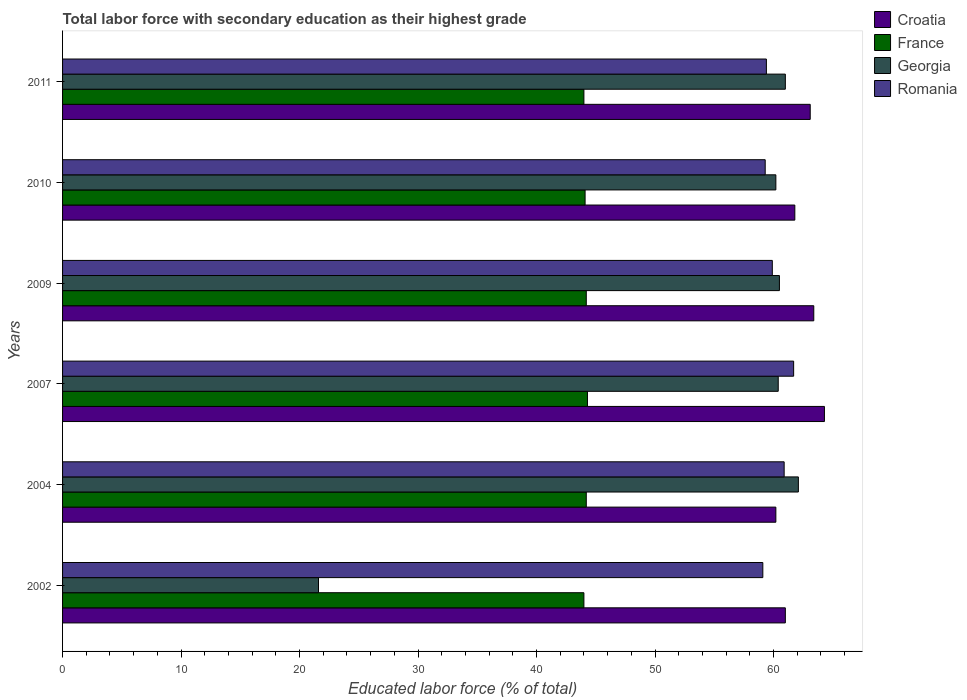How many different coloured bars are there?
Keep it short and to the point. 4. Are the number of bars per tick equal to the number of legend labels?
Offer a very short reply. Yes. Are the number of bars on each tick of the Y-axis equal?
Provide a succinct answer. Yes. How many bars are there on the 5th tick from the top?
Offer a terse response. 4. How many bars are there on the 4th tick from the bottom?
Your response must be concise. 4. In how many cases, is the number of bars for a given year not equal to the number of legend labels?
Keep it short and to the point. 0. What is the percentage of total labor force with primary education in Croatia in 2004?
Offer a terse response. 60.2. Across all years, what is the maximum percentage of total labor force with primary education in Georgia?
Provide a short and direct response. 62.1. Across all years, what is the minimum percentage of total labor force with primary education in France?
Provide a succinct answer. 44. What is the total percentage of total labor force with primary education in Croatia in the graph?
Your answer should be compact. 373.8. What is the difference between the percentage of total labor force with primary education in Romania in 2004 and that in 2010?
Provide a short and direct response. 1.6. What is the difference between the percentage of total labor force with primary education in Romania in 2009 and the percentage of total labor force with primary education in Georgia in 2011?
Offer a terse response. -1.1. What is the average percentage of total labor force with primary education in Georgia per year?
Offer a terse response. 54.3. In the year 2002, what is the difference between the percentage of total labor force with primary education in France and percentage of total labor force with primary education in Georgia?
Provide a succinct answer. 22.4. In how many years, is the percentage of total labor force with primary education in Georgia greater than 60 %?
Offer a very short reply. 5. What is the ratio of the percentage of total labor force with primary education in Croatia in 2009 to that in 2011?
Provide a short and direct response. 1. Is the difference between the percentage of total labor force with primary education in France in 2004 and 2007 greater than the difference between the percentage of total labor force with primary education in Georgia in 2004 and 2007?
Offer a very short reply. No. What is the difference between the highest and the second highest percentage of total labor force with primary education in Georgia?
Your response must be concise. 1.1. What is the difference between the highest and the lowest percentage of total labor force with primary education in Croatia?
Provide a succinct answer. 4.1. Is the sum of the percentage of total labor force with primary education in Croatia in 2007 and 2010 greater than the maximum percentage of total labor force with primary education in France across all years?
Make the answer very short. Yes. Is it the case that in every year, the sum of the percentage of total labor force with primary education in Romania and percentage of total labor force with primary education in Croatia is greater than the sum of percentage of total labor force with primary education in Georgia and percentage of total labor force with primary education in France?
Provide a short and direct response. No. What does the 2nd bar from the top in 2007 represents?
Provide a short and direct response. Georgia. What does the 4th bar from the bottom in 2010 represents?
Ensure brevity in your answer.  Romania. How many bars are there?
Provide a short and direct response. 24. Are all the bars in the graph horizontal?
Keep it short and to the point. Yes. What is the difference between two consecutive major ticks on the X-axis?
Offer a very short reply. 10. Does the graph contain any zero values?
Provide a succinct answer. No. Does the graph contain grids?
Your answer should be very brief. No. What is the title of the graph?
Keep it short and to the point. Total labor force with secondary education as their highest grade. What is the label or title of the X-axis?
Make the answer very short. Educated labor force (% of total). What is the Educated labor force (% of total) of Croatia in 2002?
Offer a very short reply. 61. What is the Educated labor force (% of total) of Georgia in 2002?
Offer a very short reply. 21.6. What is the Educated labor force (% of total) in Romania in 2002?
Offer a very short reply. 59.1. What is the Educated labor force (% of total) in Croatia in 2004?
Provide a short and direct response. 60.2. What is the Educated labor force (% of total) in France in 2004?
Make the answer very short. 44.2. What is the Educated labor force (% of total) in Georgia in 2004?
Your response must be concise. 62.1. What is the Educated labor force (% of total) of Romania in 2004?
Give a very brief answer. 60.9. What is the Educated labor force (% of total) of Croatia in 2007?
Provide a succinct answer. 64.3. What is the Educated labor force (% of total) of France in 2007?
Keep it short and to the point. 44.3. What is the Educated labor force (% of total) in Georgia in 2007?
Your response must be concise. 60.4. What is the Educated labor force (% of total) in Romania in 2007?
Offer a very short reply. 61.7. What is the Educated labor force (% of total) of Croatia in 2009?
Your answer should be compact. 63.4. What is the Educated labor force (% of total) of France in 2009?
Provide a short and direct response. 44.2. What is the Educated labor force (% of total) in Georgia in 2009?
Keep it short and to the point. 60.5. What is the Educated labor force (% of total) in Romania in 2009?
Your answer should be very brief. 59.9. What is the Educated labor force (% of total) in Croatia in 2010?
Make the answer very short. 61.8. What is the Educated labor force (% of total) of France in 2010?
Provide a succinct answer. 44.1. What is the Educated labor force (% of total) of Georgia in 2010?
Offer a terse response. 60.2. What is the Educated labor force (% of total) in Romania in 2010?
Provide a short and direct response. 59.3. What is the Educated labor force (% of total) in Croatia in 2011?
Offer a terse response. 63.1. What is the Educated labor force (% of total) of France in 2011?
Provide a short and direct response. 44. What is the Educated labor force (% of total) of Romania in 2011?
Keep it short and to the point. 59.4. Across all years, what is the maximum Educated labor force (% of total) in Croatia?
Provide a succinct answer. 64.3. Across all years, what is the maximum Educated labor force (% of total) of France?
Your response must be concise. 44.3. Across all years, what is the maximum Educated labor force (% of total) in Georgia?
Make the answer very short. 62.1. Across all years, what is the maximum Educated labor force (% of total) of Romania?
Offer a terse response. 61.7. Across all years, what is the minimum Educated labor force (% of total) of Croatia?
Your answer should be compact. 60.2. Across all years, what is the minimum Educated labor force (% of total) of France?
Offer a very short reply. 44. Across all years, what is the minimum Educated labor force (% of total) in Georgia?
Your answer should be very brief. 21.6. Across all years, what is the minimum Educated labor force (% of total) of Romania?
Your answer should be compact. 59.1. What is the total Educated labor force (% of total) in Croatia in the graph?
Offer a very short reply. 373.8. What is the total Educated labor force (% of total) of France in the graph?
Offer a terse response. 264.8. What is the total Educated labor force (% of total) in Georgia in the graph?
Your answer should be compact. 325.8. What is the total Educated labor force (% of total) in Romania in the graph?
Offer a very short reply. 360.3. What is the difference between the Educated labor force (% of total) in Croatia in 2002 and that in 2004?
Your response must be concise. 0.8. What is the difference between the Educated labor force (% of total) of Georgia in 2002 and that in 2004?
Offer a very short reply. -40.5. What is the difference between the Educated labor force (% of total) of Romania in 2002 and that in 2004?
Provide a short and direct response. -1.8. What is the difference between the Educated labor force (% of total) in Croatia in 2002 and that in 2007?
Your answer should be very brief. -3.3. What is the difference between the Educated labor force (% of total) in Georgia in 2002 and that in 2007?
Your answer should be compact. -38.8. What is the difference between the Educated labor force (% of total) in Georgia in 2002 and that in 2009?
Provide a succinct answer. -38.9. What is the difference between the Educated labor force (% of total) in Croatia in 2002 and that in 2010?
Provide a succinct answer. -0.8. What is the difference between the Educated labor force (% of total) of Georgia in 2002 and that in 2010?
Offer a terse response. -38.6. What is the difference between the Educated labor force (% of total) of France in 2002 and that in 2011?
Your answer should be very brief. 0. What is the difference between the Educated labor force (% of total) in Georgia in 2002 and that in 2011?
Make the answer very short. -39.4. What is the difference between the Educated labor force (% of total) in Croatia in 2004 and that in 2007?
Ensure brevity in your answer.  -4.1. What is the difference between the Educated labor force (% of total) of France in 2004 and that in 2009?
Provide a short and direct response. 0. What is the difference between the Educated labor force (% of total) of Croatia in 2004 and that in 2010?
Your response must be concise. -1.6. What is the difference between the Educated labor force (% of total) in France in 2004 and that in 2010?
Your answer should be very brief. 0.1. What is the difference between the Educated labor force (% of total) in Croatia in 2007 and that in 2009?
Provide a short and direct response. 0.9. What is the difference between the Educated labor force (% of total) in France in 2007 and that in 2009?
Your answer should be compact. 0.1. What is the difference between the Educated labor force (% of total) of Georgia in 2007 and that in 2010?
Provide a short and direct response. 0.2. What is the difference between the Educated labor force (% of total) of Georgia in 2007 and that in 2011?
Provide a succinct answer. -0.6. What is the difference between the Educated labor force (% of total) in Croatia in 2009 and that in 2011?
Give a very brief answer. 0.3. What is the difference between the Educated labor force (% of total) of Romania in 2009 and that in 2011?
Provide a short and direct response. 0.5. What is the difference between the Educated labor force (% of total) of France in 2010 and that in 2011?
Ensure brevity in your answer.  0.1. What is the difference between the Educated labor force (% of total) of Croatia in 2002 and the Educated labor force (% of total) of France in 2004?
Your response must be concise. 16.8. What is the difference between the Educated labor force (% of total) of Croatia in 2002 and the Educated labor force (% of total) of Georgia in 2004?
Keep it short and to the point. -1.1. What is the difference between the Educated labor force (% of total) of France in 2002 and the Educated labor force (% of total) of Georgia in 2004?
Provide a short and direct response. -18.1. What is the difference between the Educated labor force (% of total) in France in 2002 and the Educated labor force (% of total) in Romania in 2004?
Ensure brevity in your answer.  -16.9. What is the difference between the Educated labor force (% of total) in Georgia in 2002 and the Educated labor force (% of total) in Romania in 2004?
Provide a short and direct response. -39.3. What is the difference between the Educated labor force (% of total) in Croatia in 2002 and the Educated labor force (% of total) in Georgia in 2007?
Give a very brief answer. 0.6. What is the difference between the Educated labor force (% of total) of France in 2002 and the Educated labor force (% of total) of Georgia in 2007?
Provide a succinct answer. -16.4. What is the difference between the Educated labor force (% of total) of France in 2002 and the Educated labor force (% of total) of Romania in 2007?
Your answer should be very brief. -17.7. What is the difference between the Educated labor force (% of total) of Georgia in 2002 and the Educated labor force (% of total) of Romania in 2007?
Offer a very short reply. -40.1. What is the difference between the Educated labor force (% of total) in Croatia in 2002 and the Educated labor force (% of total) in Georgia in 2009?
Provide a short and direct response. 0.5. What is the difference between the Educated labor force (% of total) of France in 2002 and the Educated labor force (% of total) of Georgia in 2009?
Give a very brief answer. -16.5. What is the difference between the Educated labor force (% of total) of France in 2002 and the Educated labor force (% of total) of Romania in 2009?
Keep it short and to the point. -15.9. What is the difference between the Educated labor force (% of total) in Georgia in 2002 and the Educated labor force (% of total) in Romania in 2009?
Your answer should be compact. -38.3. What is the difference between the Educated labor force (% of total) of Croatia in 2002 and the Educated labor force (% of total) of Romania in 2010?
Offer a very short reply. 1.7. What is the difference between the Educated labor force (% of total) of France in 2002 and the Educated labor force (% of total) of Georgia in 2010?
Offer a terse response. -16.2. What is the difference between the Educated labor force (% of total) of France in 2002 and the Educated labor force (% of total) of Romania in 2010?
Offer a very short reply. -15.3. What is the difference between the Educated labor force (% of total) of Georgia in 2002 and the Educated labor force (% of total) of Romania in 2010?
Make the answer very short. -37.7. What is the difference between the Educated labor force (% of total) in France in 2002 and the Educated labor force (% of total) in Romania in 2011?
Offer a very short reply. -15.4. What is the difference between the Educated labor force (% of total) of Georgia in 2002 and the Educated labor force (% of total) of Romania in 2011?
Provide a short and direct response. -37.8. What is the difference between the Educated labor force (% of total) in Croatia in 2004 and the Educated labor force (% of total) in Georgia in 2007?
Give a very brief answer. -0.2. What is the difference between the Educated labor force (% of total) of Croatia in 2004 and the Educated labor force (% of total) of Romania in 2007?
Offer a terse response. -1.5. What is the difference between the Educated labor force (% of total) in France in 2004 and the Educated labor force (% of total) in Georgia in 2007?
Your answer should be compact. -16.2. What is the difference between the Educated labor force (% of total) in France in 2004 and the Educated labor force (% of total) in Romania in 2007?
Offer a terse response. -17.5. What is the difference between the Educated labor force (% of total) of Georgia in 2004 and the Educated labor force (% of total) of Romania in 2007?
Your answer should be compact. 0.4. What is the difference between the Educated labor force (% of total) of Croatia in 2004 and the Educated labor force (% of total) of Romania in 2009?
Offer a terse response. 0.3. What is the difference between the Educated labor force (% of total) in France in 2004 and the Educated labor force (% of total) in Georgia in 2009?
Provide a short and direct response. -16.3. What is the difference between the Educated labor force (% of total) of France in 2004 and the Educated labor force (% of total) of Romania in 2009?
Provide a short and direct response. -15.7. What is the difference between the Educated labor force (% of total) in Croatia in 2004 and the Educated labor force (% of total) in France in 2010?
Provide a succinct answer. 16.1. What is the difference between the Educated labor force (% of total) of Croatia in 2004 and the Educated labor force (% of total) of Georgia in 2010?
Your response must be concise. 0. What is the difference between the Educated labor force (% of total) in Croatia in 2004 and the Educated labor force (% of total) in Romania in 2010?
Your response must be concise. 0.9. What is the difference between the Educated labor force (% of total) in France in 2004 and the Educated labor force (% of total) in Georgia in 2010?
Make the answer very short. -16. What is the difference between the Educated labor force (% of total) of France in 2004 and the Educated labor force (% of total) of Romania in 2010?
Provide a succinct answer. -15.1. What is the difference between the Educated labor force (% of total) of Croatia in 2004 and the Educated labor force (% of total) of France in 2011?
Give a very brief answer. 16.2. What is the difference between the Educated labor force (% of total) in Croatia in 2004 and the Educated labor force (% of total) in Romania in 2011?
Offer a terse response. 0.8. What is the difference between the Educated labor force (% of total) in France in 2004 and the Educated labor force (% of total) in Georgia in 2011?
Your answer should be very brief. -16.8. What is the difference between the Educated labor force (% of total) of France in 2004 and the Educated labor force (% of total) of Romania in 2011?
Keep it short and to the point. -15.2. What is the difference between the Educated labor force (% of total) in Georgia in 2004 and the Educated labor force (% of total) in Romania in 2011?
Your answer should be very brief. 2.7. What is the difference between the Educated labor force (% of total) of Croatia in 2007 and the Educated labor force (% of total) of France in 2009?
Your answer should be compact. 20.1. What is the difference between the Educated labor force (% of total) in Croatia in 2007 and the Educated labor force (% of total) in Romania in 2009?
Provide a succinct answer. 4.4. What is the difference between the Educated labor force (% of total) of France in 2007 and the Educated labor force (% of total) of Georgia in 2009?
Offer a terse response. -16.2. What is the difference between the Educated labor force (% of total) of France in 2007 and the Educated labor force (% of total) of Romania in 2009?
Offer a terse response. -15.6. What is the difference between the Educated labor force (% of total) of Georgia in 2007 and the Educated labor force (% of total) of Romania in 2009?
Offer a very short reply. 0.5. What is the difference between the Educated labor force (% of total) of Croatia in 2007 and the Educated labor force (% of total) of France in 2010?
Offer a terse response. 20.2. What is the difference between the Educated labor force (% of total) in Croatia in 2007 and the Educated labor force (% of total) in Georgia in 2010?
Offer a terse response. 4.1. What is the difference between the Educated labor force (% of total) in France in 2007 and the Educated labor force (% of total) in Georgia in 2010?
Ensure brevity in your answer.  -15.9. What is the difference between the Educated labor force (% of total) of France in 2007 and the Educated labor force (% of total) of Romania in 2010?
Offer a terse response. -15. What is the difference between the Educated labor force (% of total) of Croatia in 2007 and the Educated labor force (% of total) of France in 2011?
Your response must be concise. 20.3. What is the difference between the Educated labor force (% of total) in Croatia in 2007 and the Educated labor force (% of total) in Romania in 2011?
Offer a very short reply. 4.9. What is the difference between the Educated labor force (% of total) of France in 2007 and the Educated labor force (% of total) of Georgia in 2011?
Offer a very short reply. -16.7. What is the difference between the Educated labor force (% of total) of France in 2007 and the Educated labor force (% of total) of Romania in 2011?
Provide a short and direct response. -15.1. What is the difference between the Educated labor force (% of total) of Georgia in 2007 and the Educated labor force (% of total) of Romania in 2011?
Your answer should be very brief. 1. What is the difference between the Educated labor force (% of total) in Croatia in 2009 and the Educated labor force (% of total) in France in 2010?
Make the answer very short. 19.3. What is the difference between the Educated labor force (% of total) of Croatia in 2009 and the Educated labor force (% of total) of Georgia in 2010?
Ensure brevity in your answer.  3.2. What is the difference between the Educated labor force (% of total) in Croatia in 2009 and the Educated labor force (% of total) in Romania in 2010?
Give a very brief answer. 4.1. What is the difference between the Educated labor force (% of total) of France in 2009 and the Educated labor force (% of total) of Romania in 2010?
Ensure brevity in your answer.  -15.1. What is the difference between the Educated labor force (% of total) in Georgia in 2009 and the Educated labor force (% of total) in Romania in 2010?
Your response must be concise. 1.2. What is the difference between the Educated labor force (% of total) of France in 2009 and the Educated labor force (% of total) of Georgia in 2011?
Offer a very short reply. -16.8. What is the difference between the Educated labor force (% of total) of France in 2009 and the Educated labor force (% of total) of Romania in 2011?
Make the answer very short. -15.2. What is the difference between the Educated labor force (% of total) in Georgia in 2009 and the Educated labor force (% of total) in Romania in 2011?
Offer a very short reply. 1.1. What is the difference between the Educated labor force (% of total) of Croatia in 2010 and the Educated labor force (% of total) of France in 2011?
Offer a very short reply. 17.8. What is the difference between the Educated labor force (% of total) of Croatia in 2010 and the Educated labor force (% of total) of Georgia in 2011?
Ensure brevity in your answer.  0.8. What is the difference between the Educated labor force (% of total) in France in 2010 and the Educated labor force (% of total) in Georgia in 2011?
Your response must be concise. -16.9. What is the difference between the Educated labor force (% of total) in France in 2010 and the Educated labor force (% of total) in Romania in 2011?
Your answer should be compact. -15.3. What is the average Educated labor force (% of total) in Croatia per year?
Provide a succinct answer. 62.3. What is the average Educated labor force (% of total) of France per year?
Keep it short and to the point. 44.13. What is the average Educated labor force (% of total) in Georgia per year?
Offer a very short reply. 54.3. What is the average Educated labor force (% of total) of Romania per year?
Ensure brevity in your answer.  60.05. In the year 2002, what is the difference between the Educated labor force (% of total) of Croatia and Educated labor force (% of total) of France?
Give a very brief answer. 17. In the year 2002, what is the difference between the Educated labor force (% of total) of Croatia and Educated labor force (% of total) of Georgia?
Provide a short and direct response. 39.4. In the year 2002, what is the difference between the Educated labor force (% of total) in Croatia and Educated labor force (% of total) in Romania?
Offer a terse response. 1.9. In the year 2002, what is the difference between the Educated labor force (% of total) of France and Educated labor force (% of total) of Georgia?
Offer a terse response. 22.4. In the year 2002, what is the difference between the Educated labor force (% of total) of France and Educated labor force (% of total) of Romania?
Keep it short and to the point. -15.1. In the year 2002, what is the difference between the Educated labor force (% of total) in Georgia and Educated labor force (% of total) in Romania?
Provide a succinct answer. -37.5. In the year 2004, what is the difference between the Educated labor force (% of total) of Croatia and Educated labor force (% of total) of Georgia?
Provide a succinct answer. -1.9. In the year 2004, what is the difference between the Educated labor force (% of total) of Croatia and Educated labor force (% of total) of Romania?
Offer a terse response. -0.7. In the year 2004, what is the difference between the Educated labor force (% of total) in France and Educated labor force (% of total) in Georgia?
Your answer should be very brief. -17.9. In the year 2004, what is the difference between the Educated labor force (% of total) of France and Educated labor force (% of total) of Romania?
Your response must be concise. -16.7. In the year 2007, what is the difference between the Educated labor force (% of total) of Croatia and Educated labor force (% of total) of France?
Offer a very short reply. 20. In the year 2007, what is the difference between the Educated labor force (% of total) in France and Educated labor force (% of total) in Georgia?
Offer a very short reply. -16.1. In the year 2007, what is the difference between the Educated labor force (% of total) of France and Educated labor force (% of total) of Romania?
Offer a very short reply. -17.4. In the year 2009, what is the difference between the Educated labor force (% of total) of France and Educated labor force (% of total) of Georgia?
Ensure brevity in your answer.  -16.3. In the year 2009, what is the difference between the Educated labor force (% of total) of France and Educated labor force (% of total) of Romania?
Provide a short and direct response. -15.7. In the year 2009, what is the difference between the Educated labor force (% of total) in Georgia and Educated labor force (% of total) in Romania?
Keep it short and to the point. 0.6. In the year 2010, what is the difference between the Educated labor force (% of total) in Croatia and Educated labor force (% of total) in France?
Offer a very short reply. 17.7. In the year 2010, what is the difference between the Educated labor force (% of total) of Croatia and Educated labor force (% of total) of Georgia?
Offer a very short reply. 1.6. In the year 2010, what is the difference between the Educated labor force (% of total) of Croatia and Educated labor force (% of total) of Romania?
Your answer should be compact. 2.5. In the year 2010, what is the difference between the Educated labor force (% of total) in France and Educated labor force (% of total) in Georgia?
Make the answer very short. -16.1. In the year 2010, what is the difference between the Educated labor force (% of total) in France and Educated labor force (% of total) in Romania?
Offer a very short reply. -15.2. In the year 2011, what is the difference between the Educated labor force (% of total) of Croatia and Educated labor force (% of total) of France?
Ensure brevity in your answer.  19.1. In the year 2011, what is the difference between the Educated labor force (% of total) of France and Educated labor force (% of total) of Romania?
Give a very brief answer. -15.4. What is the ratio of the Educated labor force (% of total) in Croatia in 2002 to that in 2004?
Keep it short and to the point. 1.01. What is the ratio of the Educated labor force (% of total) in France in 2002 to that in 2004?
Provide a succinct answer. 1. What is the ratio of the Educated labor force (% of total) in Georgia in 2002 to that in 2004?
Keep it short and to the point. 0.35. What is the ratio of the Educated labor force (% of total) in Romania in 2002 to that in 2004?
Your response must be concise. 0.97. What is the ratio of the Educated labor force (% of total) of Croatia in 2002 to that in 2007?
Provide a short and direct response. 0.95. What is the ratio of the Educated labor force (% of total) in France in 2002 to that in 2007?
Ensure brevity in your answer.  0.99. What is the ratio of the Educated labor force (% of total) of Georgia in 2002 to that in 2007?
Make the answer very short. 0.36. What is the ratio of the Educated labor force (% of total) of Romania in 2002 to that in 2007?
Offer a terse response. 0.96. What is the ratio of the Educated labor force (% of total) of Croatia in 2002 to that in 2009?
Make the answer very short. 0.96. What is the ratio of the Educated labor force (% of total) of France in 2002 to that in 2009?
Your response must be concise. 1. What is the ratio of the Educated labor force (% of total) in Georgia in 2002 to that in 2009?
Your answer should be very brief. 0.36. What is the ratio of the Educated labor force (% of total) of Romania in 2002 to that in 2009?
Ensure brevity in your answer.  0.99. What is the ratio of the Educated labor force (% of total) in Croatia in 2002 to that in 2010?
Offer a very short reply. 0.99. What is the ratio of the Educated labor force (% of total) in Georgia in 2002 to that in 2010?
Offer a terse response. 0.36. What is the ratio of the Educated labor force (% of total) in Romania in 2002 to that in 2010?
Your answer should be very brief. 1. What is the ratio of the Educated labor force (% of total) of Croatia in 2002 to that in 2011?
Provide a succinct answer. 0.97. What is the ratio of the Educated labor force (% of total) in Georgia in 2002 to that in 2011?
Provide a short and direct response. 0.35. What is the ratio of the Educated labor force (% of total) in Romania in 2002 to that in 2011?
Give a very brief answer. 0.99. What is the ratio of the Educated labor force (% of total) in Croatia in 2004 to that in 2007?
Give a very brief answer. 0.94. What is the ratio of the Educated labor force (% of total) in France in 2004 to that in 2007?
Keep it short and to the point. 1. What is the ratio of the Educated labor force (% of total) of Georgia in 2004 to that in 2007?
Provide a short and direct response. 1.03. What is the ratio of the Educated labor force (% of total) in Croatia in 2004 to that in 2009?
Your answer should be compact. 0.95. What is the ratio of the Educated labor force (% of total) of France in 2004 to that in 2009?
Keep it short and to the point. 1. What is the ratio of the Educated labor force (% of total) of Georgia in 2004 to that in 2009?
Give a very brief answer. 1.03. What is the ratio of the Educated labor force (% of total) of Romania in 2004 to that in 2009?
Provide a succinct answer. 1.02. What is the ratio of the Educated labor force (% of total) in Croatia in 2004 to that in 2010?
Your answer should be compact. 0.97. What is the ratio of the Educated labor force (% of total) in France in 2004 to that in 2010?
Your answer should be compact. 1. What is the ratio of the Educated labor force (% of total) in Georgia in 2004 to that in 2010?
Offer a very short reply. 1.03. What is the ratio of the Educated labor force (% of total) in Romania in 2004 to that in 2010?
Ensure brevity in your answer.  1.03. What is the ratio of the Educated labor force (% of total) of Croatia in 2004 to that in 2011?
Offer a terse response. 0.95. What is the ratio of the Educated labor force (% of total) of France in 2004 to that in 2011?
Provide a short and direct response. 1. What is the ratio of the Educated labor force (% of total) in Georgia in 2004 to that in 2011?
Make the answer very short. 1.02. What is the ratio of the Educated labor force (% of total) of Romania in 2004 to that in 2011?
Offer a terse response. 1.03. What is the ratio of the Educated labor force (% of total) in Croatia in 2007 to that in 2009?
Your answer should be very brief. 1.01. What is the ratio of the Educated labor force (% of total) in Georgia in 2007 to that in 2009?
Your answer should be very brief. 1. What is the ratio of the Educated labor force (% of total) in Romania in 2007 to that in 2009?
Provide a short and direct response. 1.03. What is the ratio of the Educated labor force (% of total) of Croatia in 2007 to that in 2010?
Provide a short and direct response. 1.04. What is the ratio of the Educated labor force (% of total) in France in 2007 to that in 2010?
Your response must be concise. 1. What is the ratio of the Educated labor force (% of total) of Georgia in 2007 to that in 2010?
Offer a very short reply. 1. What is the ratio of the Educated labor force (% of total) in Romania in 2007 to that in 2010?
Make the answer very short. 1.04. What is the ratio of the Educated labor force (% of total) in Croatia in 2007 to that in 2011?
Keep it short and to the point. 1.02. What is the ratio of the Educated labor force (% of total) of France in 2007 to that in 2011?
Give a very brief answer. 1.01. What is the ratio of the Educated labor force (% of total) in Georgia in 2007 to that in 2011?
Your answer should be very brief. 0.99. What is the ratio of the Educated labor force (% of total) in Romania in 2007 to that in 2011?
Provide a short and direct response. 1.04. What is the ratio of the Educated labor force (% of total) of Croatia in 2009 to that in 2010?
Keep it short and to the point. 1.03. What is the ratio of the Educated labor force (% of total) in Georgia in 2009 to that in 2010?
Your answer should be very brief. 1. What is the ratio of the Educated labor force (% of total) of Romania in 2009 to that in 2011?
Keep it short and to the point. 1.01. What is the ratio of the Educated labor force (% of total) of Croatia in 2010 to that in 2011?
Make the answer very short. 0.98. What is the ratio of the Educated labor force (% of total) of Georgia in 2010 to that in 2011?
Keep it short and to the point. 0.99. What is the ratio of the Educated labor force (% of total) of Romania in 2010 to that in 2011?
Provide a succinct answer. 1. What is the difference between the highest and the second highest Educated labor force (% of total) in France?
Keep it short and to the point. 0.1. What is the difference between the highest and the second highest Educated labor force (% of total) in Georgia?
Offer a terse response. 1.1. What is the difference between the highest and the second highest Educated labor force (% of total) of Romania?
Offer a terse response. 0.8. What is the difference between the highest and the lowest Educated labor force (% of total) in Croatia?
Your answer should be very brief. 4.1. What is the difference between the highest and the lowest Educated labor force (% of total) in France?
Offer a terse response. 0.3. What is the difference between the highest and the lowest Educated labor force (% of total) in Georgia?
Your answer should be very brief. 40.5. 